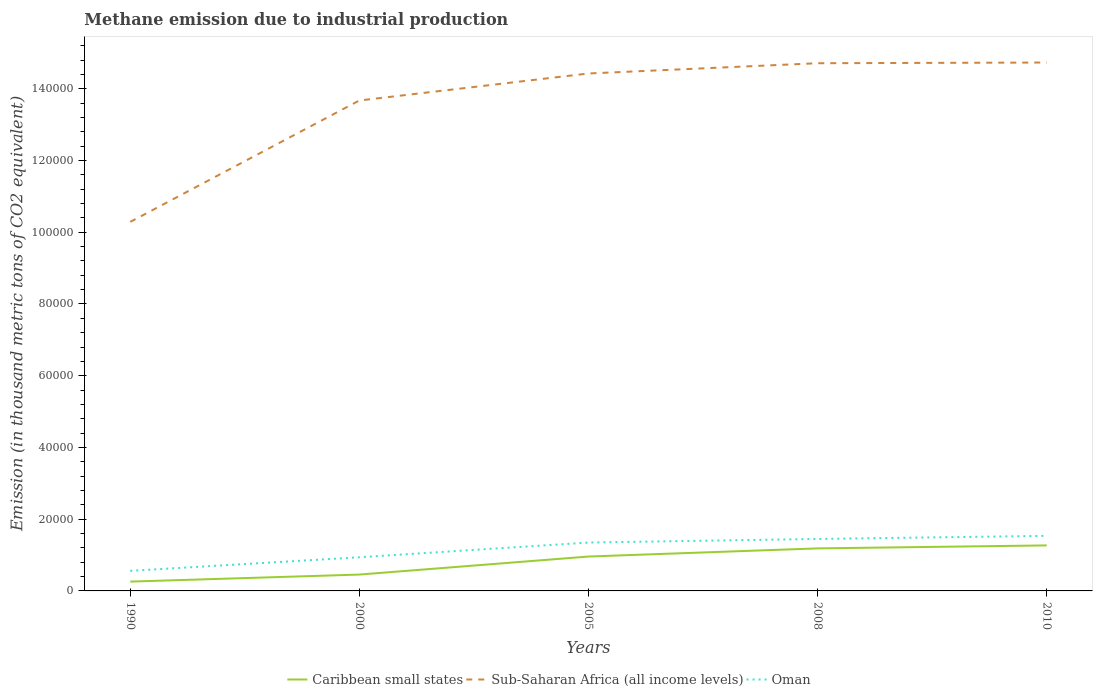How many different coloured lines are there?
Your response must be concise. 3. Does the line corresponding to Oman intersect with the line corresponding to Caribbean small states?
Ensure brevity in your answer.  No. Across all years, what is the maximum amount of methane emitted in Sub-Saharan Africa (all income levels)?
Keep it short and to the point. 1.03e+05. In which year was the amount of methane emitted in Oman maximum?
Offer a terse response. 1990. What is the total amount of methane emitted in Caribbean small states in the graph?
Provide a succinct answer. -1960.7. What is the difference between the highest and the second highest amount of methane emitted in Sub-Saharan Africa (all income levels)?
Provide a short and direct response. 4.44e+04. How many years are there in the graph?
Your answer should be very brief. 5. Does the graph contain any zero values?
Ensure brevity in your answer.  No. Does the graph contain grids?
Provide a short and direct response. No. Where does the legend appear in the graph?
Your answer should be very brief. Bottom center. How are the legend labels stacked?
Provide a succinct answer. Horizontal. What is the title of the graph?
Provide a short and direct response. Methane emission due to industrial production. Does "St. Vincent and the Grenadines" appear as one of the legend labels in the graph?
Your answer should be very brief. No. What is the label or title of the Y-axis?
Your response must be concise. Emission (in thousand metric tons of CO2 equivalent). What is the Emission (in thousand metric tons of CO2 equivalent) in Caribbean small states in 1990?
Your answer should be very brief. 2599.9. What is the Emission (in thousand metric tons of CO2 equivalent) in Sub-Saharan Africa (all income levels) in 1990?
Keep it short and to the point. 1.03e+05. What is the Emission (in thousand metric tons of CO2 equivalent) in Oman in 1990?
Provide a short and direct response. 5599.6. What is the Emission (in thousand metric tons of CO2 equivalent) of Caribbean small states in 2000?
Your answer should be very brief. 4560.6. What is the Emission (in thousand metric tons of CO2 equivalent) in Sub-Saharan Africa (all income levels) in 2000?
Ensure brevity in your answer.  1.37e+05. What is the Emission (in thousand metric tons of CO2 equivalent) of Oman in 2000?
Your answer should be compact. 9388.4. What is the Emission (in thousand metric tons of CO2 equivalent) of Caribbean small states in 2005?
Offer a terse response. 9586.6. What is the Emission (in thousand metric tons of CO2 equivalent) in Sub-Saharan Africa (all income levels) in 2005?
Offer a terse response. 1.44e+05. What is the Emission (in thousand metric tons of CO2 equivalent) of Oman in 2005?
Offer a terse response. 1.35e+04. What is the Emission (in thousand metric tons of CO2 equivalent) of Caribbean small states in 2008?
Offer a very short reply. 1.19e+04. What is the Emission (in thousand metric tons of CO2 equivalent) in Sub-Saharan Africa (all income levels) in 2008?
Provide a short and direct response. 1.47e+05. What is the Emission (in thousand metric tons of CO2 equivalent) in Oman in 2008?
Offer a very short reply. 1.45e+04. What is the Emission (in thousand metric tons of CO2 equivalent) of Caribbean small states in 2010?
Give a very brief answer. 1.27e+04. What is the Emission (in thousand metric tons of CO2 equivalent) of Sub-Saharan Africa (all income levels) in 2010?
Make the answer very short. 1.47e+05. What is the Emission (in thousand metric tons of CO2 equivalent) in Oman in 2010?
Provide a succinct answer. 1.54e+04. Across all years, what is the maximum Emission (in thousand metric tons of CO2 equivalent) of Caribbean small states?
Your answer should be compact. 1.27e+04. Across all years, what is the maximum Emission (in thousand metric tons of CO2 equivalent) in Sub-Saharan Africa (all income levels)?
Your answer should be very brief. 1.47e+05. Across all years, what is the maximum Emission (in thousand metric tons of CO2 equivalent) in Oman?
Your response must be concise. 1.54e+04. Across all years, what is the minimum Emission (in thousand metric tons of CO2 equivalent) of Caribbean small states?
Give a very brief answer. 2599.9. Across all years, what is the minimum Emission (in thousand metric tons of CO2 equivalent) of Sub-Saharan Africa (all income levels)?
Provide a short and direct response. 1.03e+05. Across all years, what is the minimum Emission (in thousand metric tons of CO2 equivalent) in Oman?
Make the answer very short. 5599.6. What is the total Emission (in thousand metric tons of CO2 equivalent) of Caribbean small states in the graph?
Offer a very short reply. 4.13e+04. What is the total Emission (in thousand metric tons of CO2 equivalent) of Sub-Saharan Africa (all income levels) in the graph?
Your answer should be compact. 6.78e+05. What is the total Emission (in thousand metric tons of CO2 equivalent) of Oman in the graph?
Keep it short and to the point. 5.83e+04. What is the difference between the Emission (in thousand metric tons of CO2 equivalent) of Caribbean small states in 1990 and that in 2000?
Your response must be concise. -1960.7. What is the difference between the Emission (in thousand metric tons of CO2 equivalent) of Sub-Saharan Africa (all income levels) in 1990 and that in 2000?
Provide a short and direct response. -3.38e+04. What is the difference between the Emission (in thousand metric tons of CO2 equivalent) in Oman in 1990 and that in 2000?
Your response must be concise. -3788.8. What is the difference between the Emission (in thousand metric tons of CO2 equivalent) of Caribbean small states in 1990 and that in 2005?
Your answer should be compact. -6986.7. What is the difference between the Emission (in thousand metric tons of CO2 equivalent) of Sub-Saharan Africa (all income levels) in 1990 and that in 2005?
Your response must be concise. -4.14e+04. What is the difference between the Emission (in thousand metric tons of CO2 equivalent) in Oman in 1990 and that in 2005?
Offer a terse response. -7887.8. What is the difference between the Emission (in thousand metric tons of CO2 equivalent) in Caribbean small states in 1990 and that in 2008?
Keep it short and to the point. -9255.6. What is the difference between the Emission (in thousand metric tons of CO2 equivalent) of Sub-Saharan Africa (all income levels) in 1990 and that in 2008?
Ensure brevity in your answer.  -4.42e+04. What is the difference between the Emission (in thousand metric tons of CO2 equivalent) of Oman in 1990 and that in 2008?
Ensure brevity in your answer.  -8889.6. What is the difference between the Emission (in thousand metric tons of CO2 equivalent) in Caribbean small states in 1990 and that in 2010?
Make the answer very short. -1.01e+04. What is the difference between the Emission (in thousand metric tons of CO2 equivalent) of Sub-Saharan Africa (all income levels) in 1990 and that in 2010?
Your response must be concise. -4.44e+04. What is the difference between the Emission (in thousand metric tons of CO2 equivalent) in Oman in 1990 and that in 2010?
Provide a short and direct response. -9757.6. What is the difference between the Emission (in thousand metric tons of CO2 equivalent) of Caribbean small states in 2000 and that in 2005?
Your answer should be compact. -5026. What is the difference between the Emission (in thousand metric tons of CO2 equivalent) of Sub-Saharan Africa (all income levels) in 2000 and that in 2005?
Your answer should be compact. -7528.2. What is the difference between the Emission (in thousand metric tons of CO2 equivalent) in Oman in 2000 and that in 2005?
Provide a short and direct response. -4099. What is the difference between the Emission (in thousand metric tons of CO2 equivalent) of Caribbean small states in 2000 and that in 2008?
Your answer should be compact. -7294.9. What is the difference between the Emission (in thousand metric tons of CO2 equivalent) of Sub-Saharan Africa (all income levels) in 2000 and that in 2008?
Make the answer very short. -1.04e+04. What is the difference between the Emission (in thousand metric tons of CO2 equivalent) in Oman in 2000 and that in 2008?
Give a very brief answer. -5100.8. What is the difference between the Emission (in thousand metric tons of CO2 equivalent) in Caribbean small states in 2000 and that in 2010?
Give a very brief answer. -8127.6. What is the difference between the Emission (in thousand metric tons of CO2 equivalent) of Sub-Saharan Africa (all income levels) in 2000 and that in 2010?
Your answer should be very brief. -1.06e+04. What is the difference between the Emission (in thousand metric tons of CO2 equivalent) of Oman in 2000 and that in 2010?
Give a very brief answer. -5968.8. What is the difference between the Emission (in thousand metric tons of CO2 equivalent) in Caribbean small states in 2005 and that in 2008?
Keep it short and to the point. -2268.9. What is the difference between the Emission (in thousand metric tons of CO2 equivalent) of Sub-Saharan Africa (all income levels) in 2005 and that in 2008?
Ensure brevity in your answer.  -2859.6. What is the difference between the Emission (in thousand metric tons of CO2 equivalent) of Oman in 2005 and that in 2008?
Ensure brevity in your answer.  -1001.8. What is the difference between the Emission (in thousand metric tons of CO2 equivalent) of Caribbean small states in 2005 and that in 2010?
Provide a succinct answer. -3101.6. What is the difference between the Emission (in thousand metric tons of CO2 equivalent) of Sub-Saharan Africa (all income levels) in 2005 and that in 2010?
Offer a very short reply. -3051.9. What is the difference between the Emission (in thousand metric tons of CO2 equivalent) in Oman in 2005 and that in 2010?
Ensure brevity in your answer.  -1869.8. What is the difference between the Emission (in thousand metric tons of CO2 equivalent) of Caribbean small states in 2008 and that in 2010?
Your response must be concise. -832.7. What is the difference between the Emission (in thousand metric tons of CO2 equivalent) in Sub-Saharan Africa (all income levels) in 2008 and that in 2010?
Offer a very short reply. -192.3. What is the difference between the Emission (in thousand metric tons of CO2 equivalent) in Oman in 2008 and that in 2010?
Your response must be concise. -868. What is the difference between the Emission (in thousand metric tons of CO2 equivalent) of Caribbean small states in 1990 and the Emission (in thousand metric tons of CO2 equivalent) of Sub-Saharan Africa (all income levels) in 2000?
Provide a succinct answer. -1.34e+05. What is the difference between the Emission (in thousand metric tons of CO2 equivalent) of Caribbean small states in 1990 and the Emission (in thousand metric tons of CO2 equivalent) of Oman in 2000?
Your answer should be very brief. -6788.5. What is the difference between the Emission (in thousand metric tons of CO2 equivalent) in Sub-Saharan Africa (all income levels) in 1990 and the Emission (in thousand metric tons of CO2 equivalent) in Oman in 2000?
Ensure brevity in your answer.  9.35e+04. What is the difference between the Emission (in thousand metric tons of CO2 equivalent) of Caribbean small states in 1990 and the Emission (in thousand metric tons of CO2 equivalent) of Sub-Saharan Africa (all income levels) in 2005?
Your answer should be compact. -1.42e+05. What is the difference between the Emission (in thousand metric tons of CO2 equivalent) in Caribbean small states in 1990 and the Emission (in thousand metric tons of CO2 equivalent) in Oman in 2005?
Your answer should be compact. -1.09e+04. What is the difference between the Emission (in thousand metric tons of CO2 equivalent) in Sub-Saharan Africa (all income levels) in 1990 and the Emission (in thousand metric tons of CO2 equivalent) in Oman in 2005?
Offer a very short reply. 8.94e+04. What is the difference between the Emission (in thousand metric tons of CO2 equivalent) in Caribbean small states in 1990 and the Emission (in thousand metric tons of CO2 equivalent) in Sub-Saharan Africa (all income levels) in 2008?
Your answer should be very brief. -1.45e+05. What is the difference between the Emission (in thousand metric tons of CO2 equivalent) of Caribbean small states in 1990 and the Emission (in thousand metric tons of CO2 equivalent) of Oman in 2008?
Your answer should be very brief. -1.19e+04. What is the difference between the Emission (in thousand metric tons of CO2 equivalent) in Sub-Saharan Africa (all income levels) in 1990 and the Emission (in thousand metric tons of CO2 equivalent) in Oman in 2008?
Offer a terse response. 8.84e+04. What is the difference between the Emission (in thousand metric tons of CO2 equivalent) in Caribbean small states in 1990 and the Emission (in thousand metric tons of CO2 equivalent) in Sub-Saharan Africa (all income levels) in 2010?
Ensure brevity in your answer.  -1.45e+05. What is the difference between the Emission (in thousand metric tons of CO2 equivalent) in Caribbean small states in 1990 and the Emission (in thousand metric tons of CO2 equivalent) in Oman in 2010?
Give a very brief answer. -1.28e+04. What is the difference between the Emission (in thousand metric tons of CO2 equivalent) of Sub-Saharan Africa (all income levels) in 1990 and the Emission (in thousand metric tons of CO2 equivalent) of Oman in 2010?
Your answer should be compact. 8.75e+04. What is the difference between the Emission (in thousand metric tons of CO2 equivalent) in Caribbean small states in 2000 and the Emission (in thousand metric tons of CO2 equivalent) in Sub-Saharan Africa (all income levels) in 2005?
Your answer should be compact. -1.40e+05. What is the difference between the Emission (in thousand metric tons of CO2 equivalent) in Caribbean small states in 2000 and the Emission (in thousand metric tons of CO2 equivalent) in Oman in 2005?
Ensure brevity in your answer.  -8926.8. What is the difference between the Emission (in thousand metric tons of CO2 equivalent) in Sub-Saharan Africa (all income levels) in 2000 and the Emission (in thousand metric tons of CO2 equivalent) in Oman in 2005?
Give a very brief answer. 1.23e+05. What is the difference between the Emission (in thousand metric tons of CO2 equivalent) of Caribbean small states in 2000 and the Emission (in thousand metric tons of CO2 equivalent) of Sub-Saharan Africa (all income levels) in 2008?
Keep it short and to the point. -1.43e+05. What is the difference between the Emission (in thousand metric tons of CO2 equivalent) in Caribbean small states in 2000 and the Emission (in thousand metric tons of CO2 equivalent) in Oman in 2008?
Provide a succinct answer. -9928.6. What is the difference between the Emission (in thousand metric tons of CO2 equivalent) of Sub-Saharan Africa (all income levels) in 2000 and the Emission (in thousand metric tons of CO2 equivalent) of Oman in 2008?
Provide a short and direct response. 1.22e+05. What is the difference between the Emission (in thousand metric tons of CO2 equivalent) of Caribbean small states in 2000 and the Emission (in thousand metric tons of CO2 equivalent) of Sub-Saharan Africa (all income levels) in 2010?
Your answer should be very brief. -1.43e+05. What is the difference between the Emission (in thousand metric tons of CO2 equivalent) of Caribbean small states in 2000 and the Emission (in thousand metric tons of CO2 equivalent) of Oman in 2010?
Provide a short and direct response. -1.08e+04. What is the difference between the Emission (in thousand metric tons of CO2 equivalent) in Sub-Saharan Africa (all income levels) in 2000 and the Emission (in thousand metric tons of CO2 equivalent) in Oman in 2010?
Make the answer very short. 1.21e+05. What is the difference between the Emission (in thousand metric tons of CO2 equivalent) in Caribbean small states in 2005 and the Emission (in thousand metric tons of CO2 equivalent) in Sub-Saharan Africa (all income levels) in 2008?
Make the answer very short. -1.38e+05. What is the difference between the Emission (in thousand metric tons of CO2 equivalent) of Caribbean small states in 2005 and the Emission (in thousand metric tons of CO2 equivalent) of Oman in 2008?
Your answer should be compact. -4902.6. What is the difference between the Emission (in thousand metric tons of CO2 equivalent) of Sub-Saharan Africa (all income levels) in 2005 and the Emission (in thousand metric tons of CO2 equivalent) of Oman in 2008?
Your response must be concise. 1.30e+05. What is the difference between the Emission (in thousand metric tons of CO2 equivalent) in Caribbean small states in 2005 and the Emission (in thousand metric tons of CO2 equivalent) in Sub-Saharan Africa (all income levels) in 2010?
Ensure brevity in your answer.  -1.38e+05. What is the difference between the Emission (in thousand metric tons of CO2 equivalent) in Caribbean small states in 2005 and the Emission (in thousand metric tons of CO2 equivalent) in Oman in 2010?
Your response must be concise. -5770.6. What is the difference between the Emission (in thousand metric tons of CO2 equivalent) of Sub-Saharan Africa (all income levels) in 2005 and the Emission (in thousand metric tons of CO2 equivalent) of Oman in 2010?
Offer a very short reply. 1.29e+05. What is the difference between the Emission (in thousand metric tons of CO2 equivalent) of Caribbean small states in 2008 and the Emission (in thousand metric tons of CO2 equivalent) of Sub-Saharan Africa (all income levels) in 2010?
Offer a very short reply. -1.35e+05. What is the difference between the Emission (in thousand metric tons of CO2 equivalent) of Caribbean small states in 2008 and the Emission (in thousand metric tons of CO2 equivalent) of Oman in 2010?
Give a very brief answer. -3501.7. What is the difference between the Emission (in thousand metric tons of CO2 equivalent) in Sub-Saharan Africa (all income levels) in 2008 and the Emission (in thousand metric tons of CO2 equivalent) in Oman in 2010?
Provide a short and direct response. 1.32e+05. What is the average Emission (in thousand metric tons of CO2 equivalent) of Caribbean small states per year?
Provide a short and direct response. 8258.16. What is the average Emission (in thousand metric tons of CO2 equivalent) of Sub-Saharan Africa (all income levels) per year?
Your response must be concise. 1.36e+05. What is the average Emission (in thousand metric tons of CO2 equivalent) of Oman per year?
Your response must be concise. 1.17e+04. In the year 1990, what is the difference between the Emission (in thousand metric tons of CO2 equivalent) of Caribbean small states and Emission (in thousand metric tons of CO2 equivalent) of Sub-Saharan Africa (all income levels)?
Give a very brief answer. -1.00e+05. In the year 1990, what is the difference between the Emission (in thousand metric tons of CO2 equivalent) in Caribbean small states and Emission (in thousand metric tons of CO2 equivalent) in Oman?
Your response must be concise. -2999.7. In the year 1990, what is the difference between the Emission (in thousand metric tons of CO2 equivalent) in Sub-Saharan Africa (all income levels) and Emission (in thousand metric tons of CO2 equivalent) in Oman?
Offer a terse response. 9.73e+04. In the year 2000, what is the difference between the Emission (in thousand metric tons of CO2 equivalent) of Caribbean small states and Emission (in thousand metric tons of CO2 equivalent) of Sub-Saharan Africa (all income levels)?
Provide a short and direct response. -1.32e+05. In the year 2000, what is the difference between the Emission (in thousand metric tons of CO2 equivalent) of Caribbean small states and Emission (in thousand metric tons of CO2 equivalent) of Oman?
Provide a short and direct response. -4827.8. In the year 2000, what is the difference between the Emission (in thousand metric tons of CO2 equivalent) of Sub-Saharan Africa (all income levels) and Emission (in thousand metric tons of CO2 equivalent) of Oman?
Offer a very short reply. 1.27e+05. In the year 2005, what is the difference between the Emission (in thousand metric tons of CO2 equivalent) in Caribbean small states and Emission (in thousand metric tons of CO2 equivalent) in Sub-Saharan Africa (all income levels)?
Provide a succinct answer. -1.35e+05. In the year 2005, what is the difference between the Emission (in thousand metric tons of CO2 equivalent) in Caribbean small states and Emission (in thousand metric tons of CO2 equivalent) in Oman?
Make the answer very short. -3900.8. In the year 2005, what is the difference between the Emission (in thousand metric tons of CO2 equivalent) in Sub-Saharan Africa (all income levels) and Emission (in thousand metric tons of CO2 equivalent) in Oman?
Ensure brevity in your answer.  1.31e+05. In the year 2008, what is the difference between the Emission (in thousand metric tons of CO2 equivalent) of Caribbean small states and Emission (in thousand metric tons of CO2 equivalent) of Sub-Saharan Africa (all income levels)?
Your answer should be compact. -1.35e+05. In the year 2008, what is the difference between the Emission (in thousand metric tons of CO2 equivalent) in Caribbean small states and Emission (in thousand metric tons of CO2 equivalent) in Oman?
Offer a very short reply. -2633.7. In the year 2008, what is the difference between the Emission (in thousand metric tons of CO2 equivalent) in Sub-Saharan Africa (all income levels) and Emission (in thousand metric tons of CO2 equivalent) in Oman?
Ensure brevity in your answer.  1.33e+05. In the year 2010, what is the difference between the Emission (in thousand metric tons of CO2 equivalent) of Caribbean small states and Emission (in thousand metric tons of CO2 equivalent) of Sub-Saharan Africa (all income levels)?
Make the answer very short. -1.35e+05. In the year 2010, what is the difference between the Emission (in thousand metric tons of CO2 equivalent) in Caribbean small states and Emission (in thousand metric tons of CO2 equivalent) in Oman?
Keep it short and to the point. -2669. In the year 2010, what is the difference between the Emission (in thousand metric tons of CO2 equivalent) of Sub-Saharan Africa (all income levels) and Emission (in thousand metric tons of CO2 equivalent) of Oman?
Provide a succinct answer. 1.32e+05. What is the ratio of the Emission (in thousand metric tons of CO2 equivalent) in Caribbean small states in 1990 to that in 2000?
Give a very brief answer. 0.57. What is the ratio of the Emission (in thousand metric tons of CO2 equivalent) in Sub-Saharan Africa (all income levels) in 1990 to that in 2000?
Your answer should be compact. 0.75. What is the ratio of the Emission (in thousand metric tons of CO2 equivalent) in Oman in 1990 to that in 2000?
Offer a very short reply. 0.6. What is the ratio of the Emission (in thousand metric tons of CO2 equivalent) in Caribbean small states in 1990 to that in 2005?
Offer a very short reply. 0.27. What is the ratio of the Emission (in thousand metric tons of CO2 equivalent) in Sub-Saharan Africa (all income levels) in 1990 to that in 2005?
Offer a very short reply. 0.71. What is the ratio of the Emission (in thousand metric tons of CO2 equivalent) of Oman in 1990 to that in 2005?
Ensure brevity in your answer.  0.42. What is the ratio of the Emission (in thousand metric tons of CO2 equivalent) in Caribbean small states in 1990 to that in 2008?
Make the answer very short. 0.22. What is the ratio of the Emission (in thousand metric tons of CO2 equivalent) in Sub-Saharan Africa (all income levels) in 1990 to that in 2008?
Give a very brief answer. 0.7. What is the ratio of the Emission (in thousand metric tons of CO2 equivalent) of Oman in 1990 to that in 2008?
Ensure brevity in your answer.  0.39. What is the ratio of the Emission (in thousand metric tons of CO2 equivalent) in Caribbean small states in 1990 to that in 2010?
Offer a very short reply. 0.2. What is the ratio of the Emission (in thousand metric tons of CO2 equivalent) of Sub-Saharan Africa (all income levels) in 1990 to that in 2010?
Ensure brevity in your answer.  0.7. What is the ratio of the Emission (in thousand metric tons of CO2 equivalent) in Oman in 1990 to that in 2010?
Your response must be concise. 0.36. What is the ratio of the Emission (in thousand metric tons of CO2 equivalent) in Caribbean small states in 2000 to that in 2005?
Offer a very short reply. 0.48. What is the ratio of the Emission (in thousand metric tons of CO2 equivalent) in Sub-Saharan Africa (all income levels) in 2000 to that in 2005?
Provide a succinct answer. 0.95. What is the ratio of the Emission (in thousand metric tons of CO2 equivalent) of Oman in 2000 to that in 2005?
Provide a short and direct response. 0.7. What is the ratio of the Emission (in thousand metric tons of CO2 equivalent) in Caribbean small states in 2000 to that in 2008?
Keep it short and to the point. 0.38. What is the ratio of the Emission (in thousand metric tons of CO2 equivalent) of Sub-Saharan Africa (all income levels) in 2000 to that in 2008?
Your answer should be compact. 0.93. What is the ratio of the Emission (in thousand metric tons of CO2 equivalent) of Oman in 2000 to that in 2008?
Provide a succinct answer. 0.65. What is the ratio of the Emission (in thousand metric tons of CO2 equivalent) in Caribbean small states in 2000 to that in 2010?
Provide a short and direct response. 0.36. What is the ratio of the Emission (in thousand metric tons of CO2 equivalent) in Sub-Saharan Africa (all income levels) in 2000 to that in 2010?
Your response must be concise. 0.93. What is the ratio of the Emission (in thousand metric tons of CO2 equivalent) of Oman in 2000 to that in 2010?
Keep it short and to the point. 0.61. What is the ratio of the Emission (in thousand metric tons of CO2 equivalent) of Caribbean small states in 2005 to that in 2008?
Offer a very short reply. 0.81. What is the ratio of the Emission (in thousand metric tons of CO2 equivalent) in Sub-Saharan Africa (all income levels) in 2005 to that in 2008?
Make the answer very short. 0.98. What is the ratio of the Emission (in thousand metric tons of CO2 equivalent) in Oman in 2005 to that in 2008?
Your answer should be very brief. 0.93. What is the ratio of the Emission (in thousand metric tons of CO2 equivalent) in Caribbean small states in 2005 to that in 2010?
Provide a succinct answer. 0.76. What is the ratio of the Emission (in thousand metric tons of CO2 equivalent) of Sub-Saharan Africa (all income levels) in 2005 to that in 2010?
Offer a very short reply. 0.98. What is the ratio of the Emission (in thousand metric tons of CO2 equivalent) of Oman in 2005 to that in 2010?
Make the answer very short. 0.88. What is the ratio of the Emission (in thousand metric tons of CO2 equivalent) of Caribbean small states in 2008 to that in 2010?
Offer a very short reply. 0.93. What is the ratio of the Emission (in thousand metric tons of CO2 equivalent) of Oman in 2008 to that in 2010?
Make the answer very short. 0.94. What is the difference between the highest and the second highest Emission (in thousand metric tons of CO2 equivalent) in Caribbean small states?
Keep it short and to the point. 832.7. What is the difference between the highest and the second highest Emission (in thousand metric tons of CO2 equivalent) in Sub-Saharan Africa (all income levels)?
Keep it short and to the point. 192.3. What is the difference between the highest and the second highest Emission (in thousand metric tons of CO2 equivalent) of Oman?
Give a very brief answer. 868. What is the difference between the highest and the lowest Emission (in thousand metric tons of CO2 equivalent) in Caribbean small states?
Keep it short and to the point. 1.01e+04. What is the difference between the highest and the lowest Emission (in thousand metric tons of CO2 equivalent) of Sub-Saharan Africa (all income levels)?
Give a very brief answer. 4.44e+04. What is the difference between the highest and the lowest Emission (in thousand metric tons of CO2 equivalent) in Oman?
Give a very brief answer. 9757.6. 